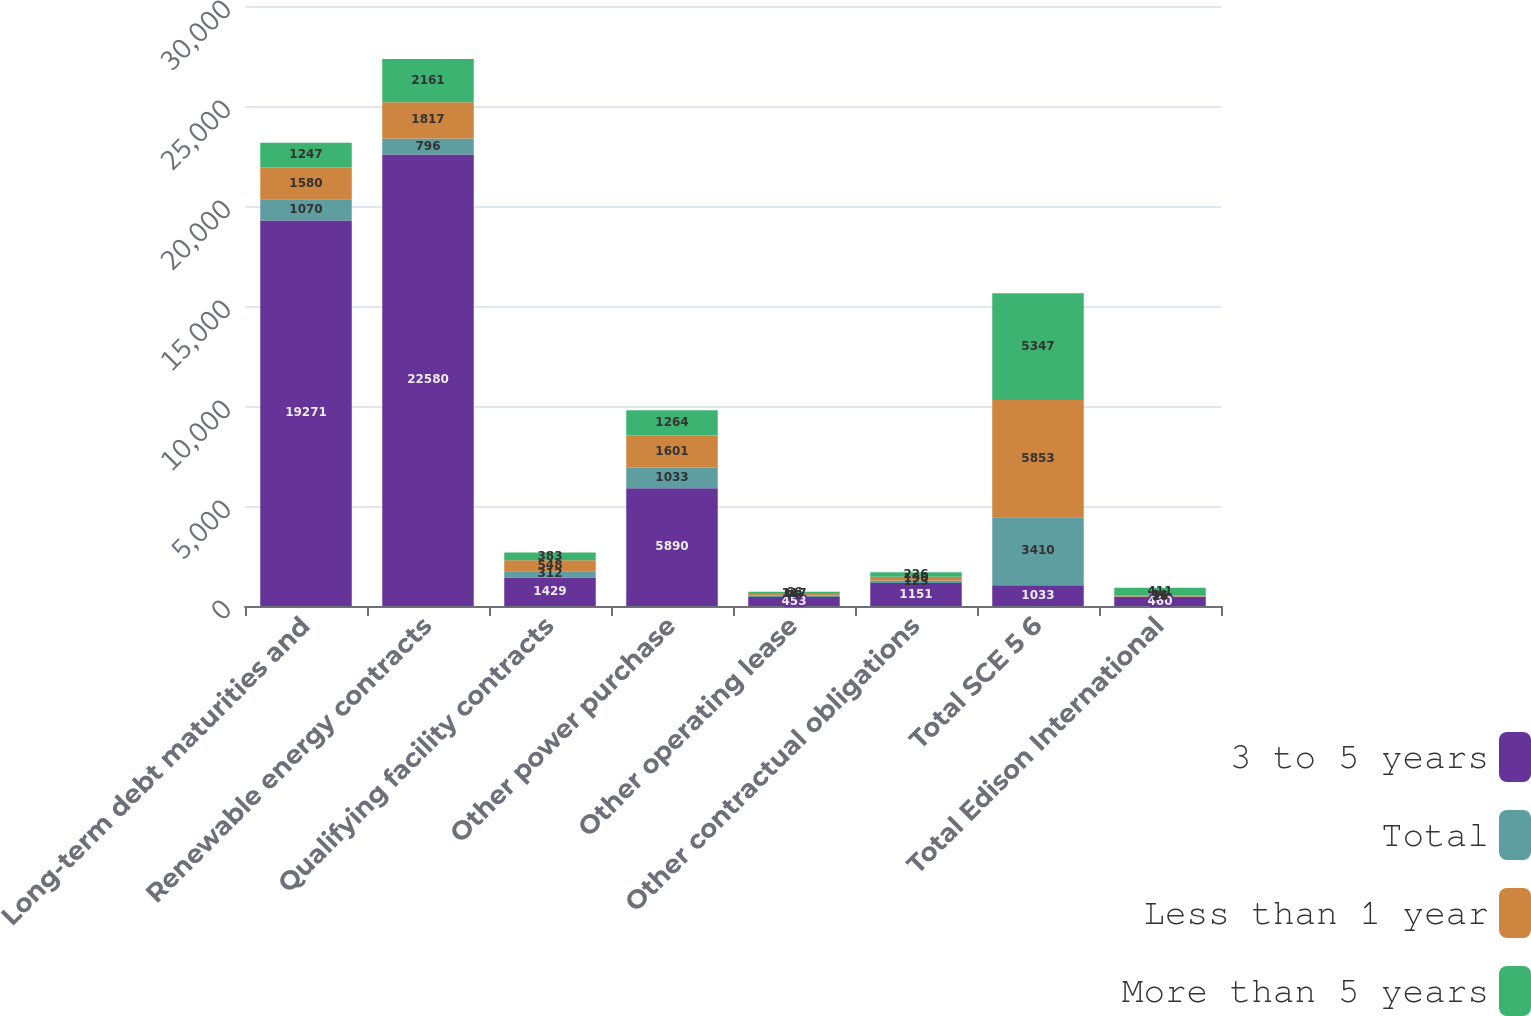<chart> <loc_0><loc_0><loc_500><loc_500><stacked_bar_chart><ecel><fcel>Long-term debt maturities and<fcel>Renewable energy contracts<fcel>Qualifying facility contracts<fcel>Other power purchase<fcel>Other operating lease<fcel>Other contractual obligations<fcel>Total SCE 5 6<fcel>Total Edison International<nl><fcel>3 to 5 years<fcel>19271<fcel>22580<fcel>1429<fcel>5890<fcel>453<fcel>1151<fcel>1033<fcel>460<nl><fcel>Total<fcel>1070<fcel>796<fcel>312<fcel>1033<fcel>76<fcel>123<fcel>3410<fcel>16<nl><fcel>Less than 1 year<fcel>1580<fcel>1817<fcel>548<fcel>1601<fcel>117<fcel>190<fcel>5853<fcel>31<nl><fcel>More than 5 years<fcel>1247<fcel>2161<fcel>383<fcel>1264<fcel>66<fcel>226<fcel>5347<fcel>411<nl></chart> 